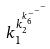Convert formula to latex. <formula><loc_0><loc_0><loc_500><loc_500>k _ { 1 } ^ { k _ { 2 } ^ { k _ { 6 } ^ { - ^ { - ^ { - } } } } }</formula> 